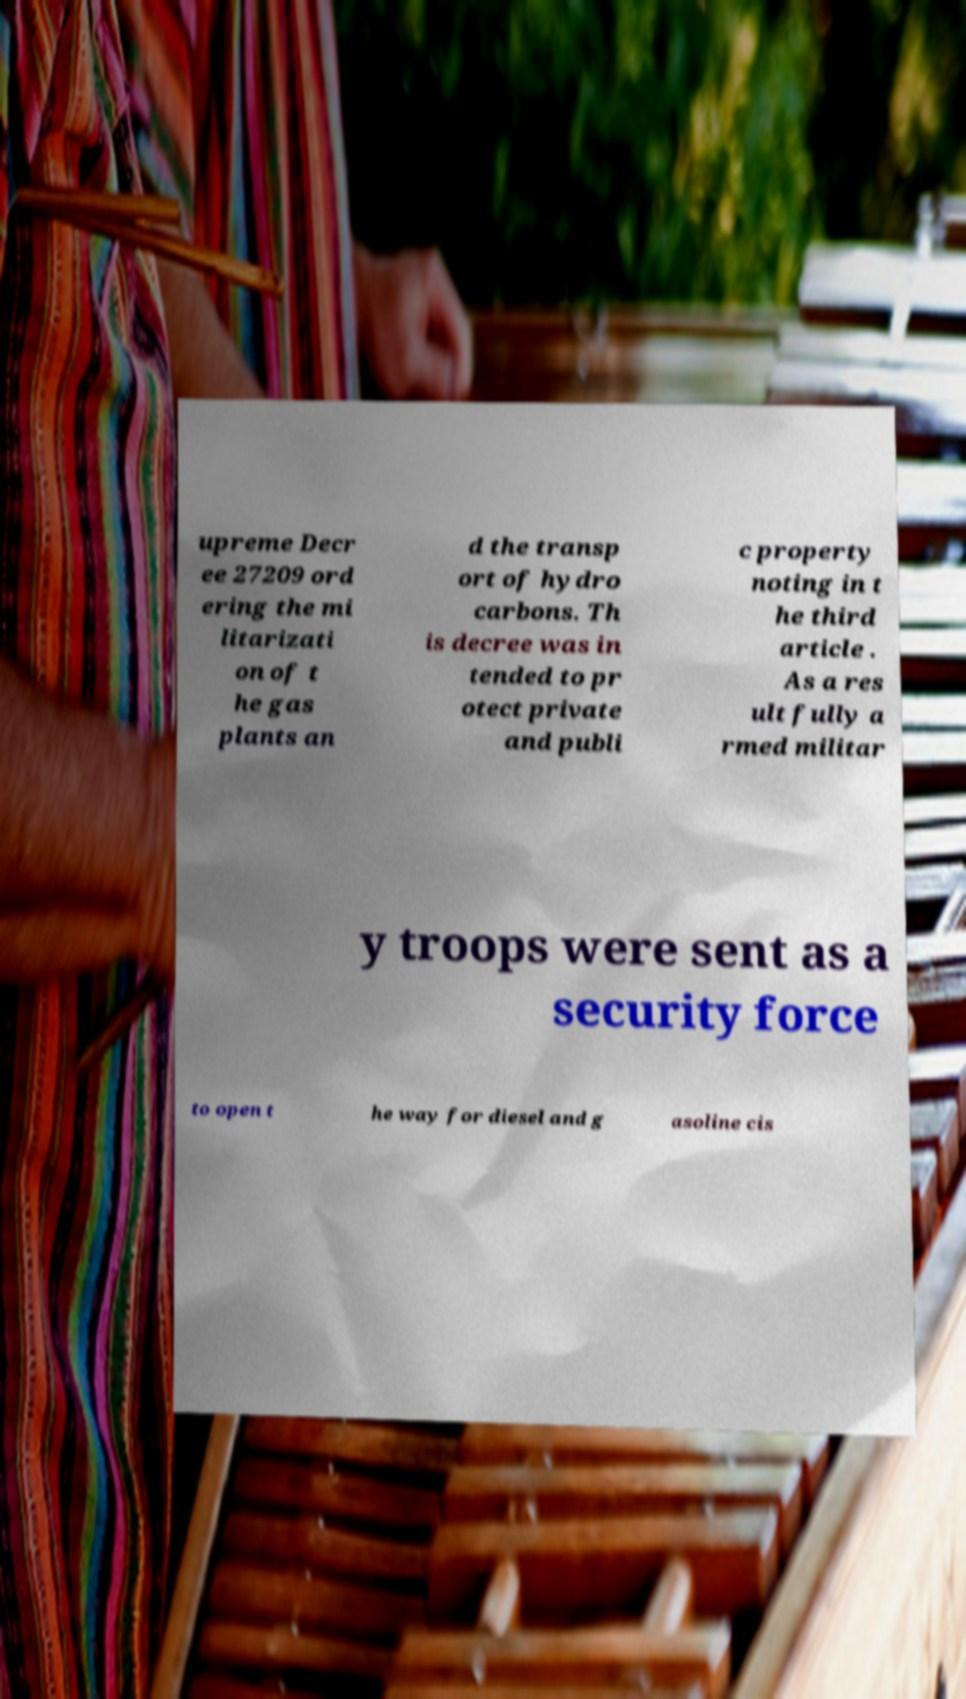Please read and relay the text visible in this image. What does it say? upreme Decr ee 27209 ord ering the mi litarizati on of t he gas plants an d the transp ort of hydro carbons. Th is decree was in tended to pr otect private and publi c property noting in t he third article . As a res ult fully a rmed militar y troops were sent as a security force to open t he way for diesel and g asoline cis 